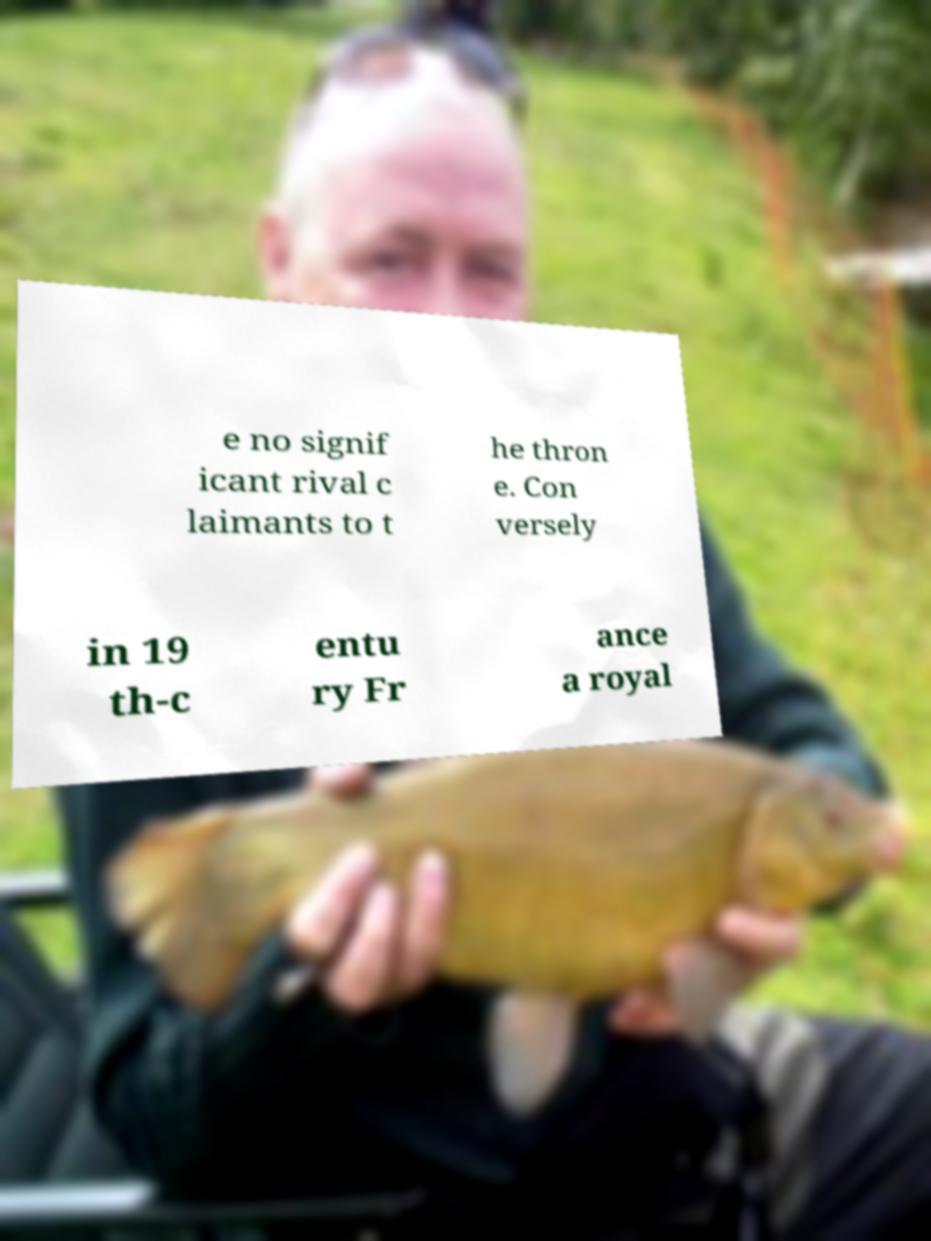What messages or text are displayed in this image? I need them in a readable, typed format. e no signif icant rival c laimants to t he thron e. Con versely in 19 th-c entu ry Fr ance a royal 